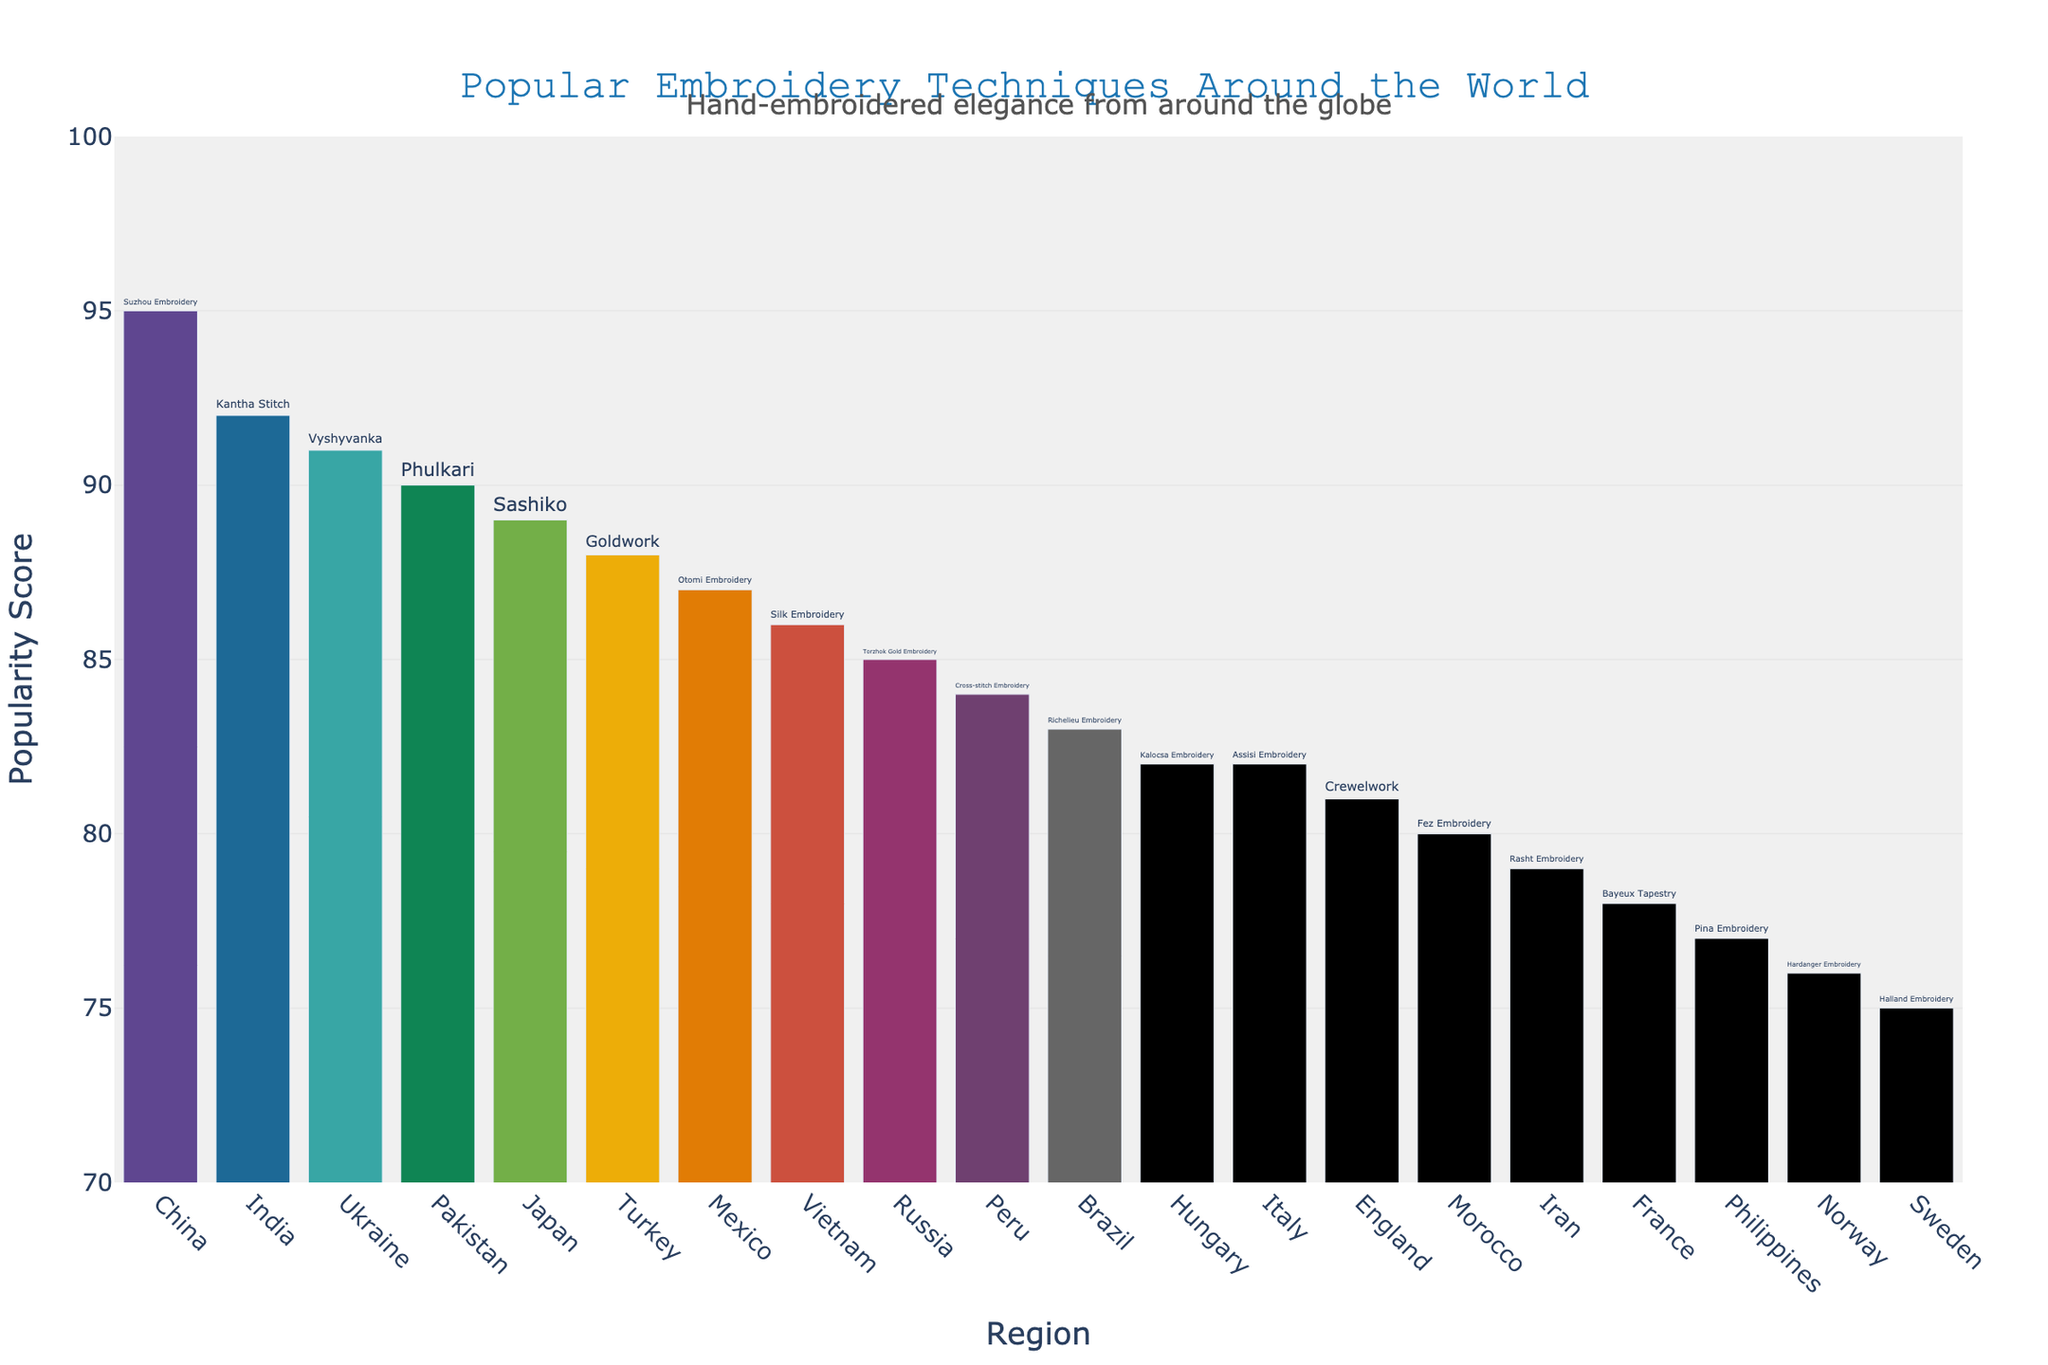Which region has the highest popularity score for its embroidery technique? The region with the highest popularity score can be identified by locating the tallest bar in the bar chart.
Answer: China What is the average popularity score of the embroidery techniques presented in the chart? To find the average, sum all the popularity scores and divide by the number of regions. (95 + 87 + 92 + 78 + 89 + 82 + 85 + 79 + 76 + 91 + 83 + 88 + 86 + 81 + 84 + 75 + 80 + 77 + 90 + 82) / 20 = 82.5
Answer: 82.5 Which embroidery technique is associated with the least popular region? The least popular region corresponds to the shortest bar in the chart.
Answer: Sweden (Halland Embroidery) How many regions have a popularity score greater than 85? Count the number of bars with a popularity score higher than 85.
Answer: 9 What's the popularity score difference between Vietnamese Silk Embroidery and English Crewelwork? Identify the bars for Vietnamese and English regions and calculate the difference in their popularity scores, 86 - 81 = 5.
Answer: 5 Compare the popularity scores of Pakistan’s Phulkari and India’s Kantha Stitch. Which one is higher and by how much? Locate both bars, noting their respective scores, and calculate the difference: 92 - 90 = 2.
Answer: India (by 2) Which regions have embroidery techniques with a popularity score between 80 and 85, inclusive? Identify and list regions with popularity scores in the 80-85 range.
Answer: Hungary, Brazil, England, Peru, Italy, Morocco Are there more regions with popularity scores above or below 82.5? Compare the number of bars above 82.5 to those below.
Answer: More above (11 above, 9 below) What is the combined popularity score of Turkey and Mexico's embroidery techniques? Sum the popularity scores of Turkey and Mexico: 88 + 87 = 175.
Answer: 175 Does Norway's Hardanger Embroidery have a higher or lower popularity score than Iran's Rasht Embroidery and by how much? Compare the popularity scores of Norway and Iran and compute the difference, 79 - 76 = 3.
Answer: Iran (by 3) 